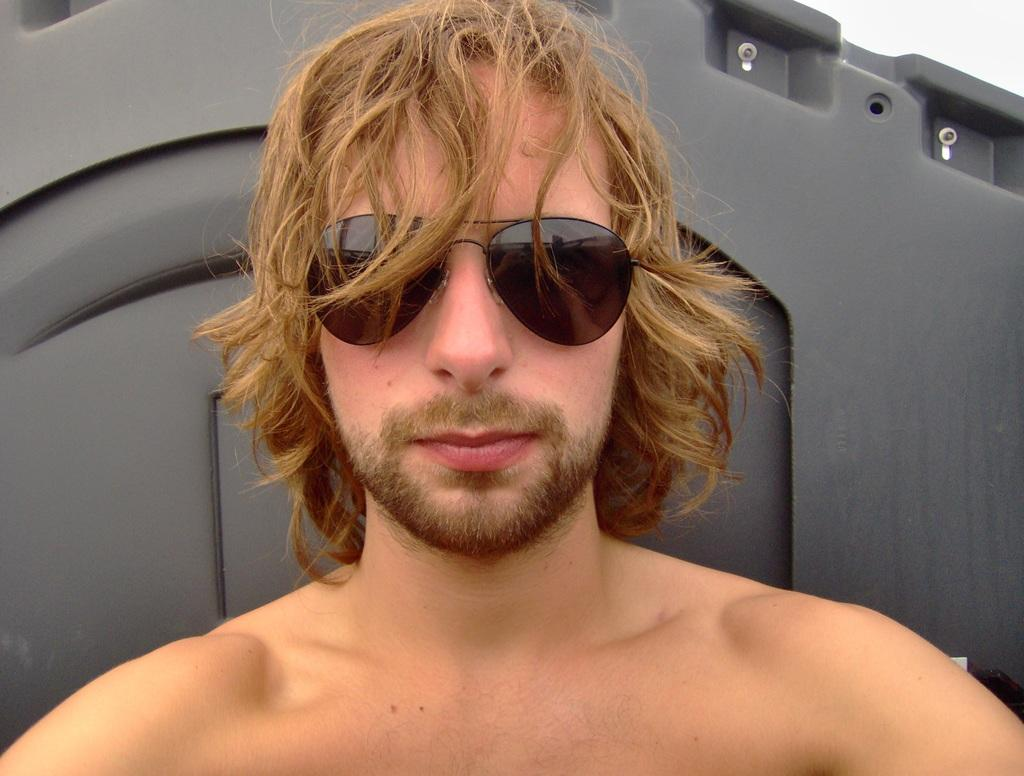Where was the image taken? The image was taken outdoors. What can be seen in the background of the image? There is a black surface in the background of the image. Who is the main subject in the image? There is a man in the middle of the image. What is the man wearing in the image? The man is wearing goggles. How many chins does the man have in the image? The number of chins cannot be determined from the image, as it only shows the man's face from a distance. 